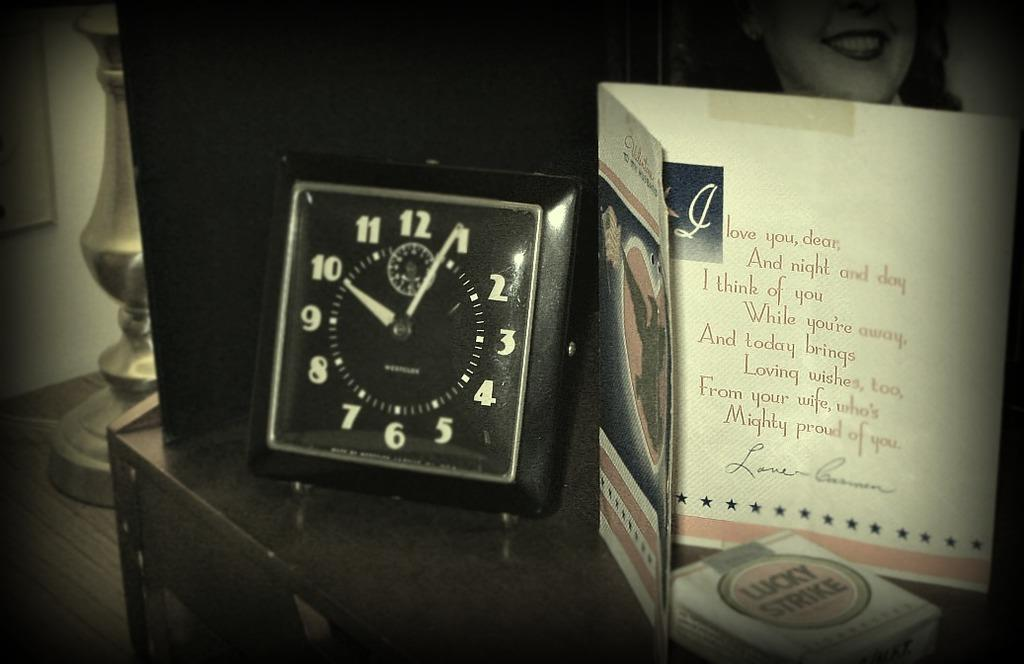<image>
Write a terse but informative summary of the picture. A black alarm clock is next to a card that says Love you. 